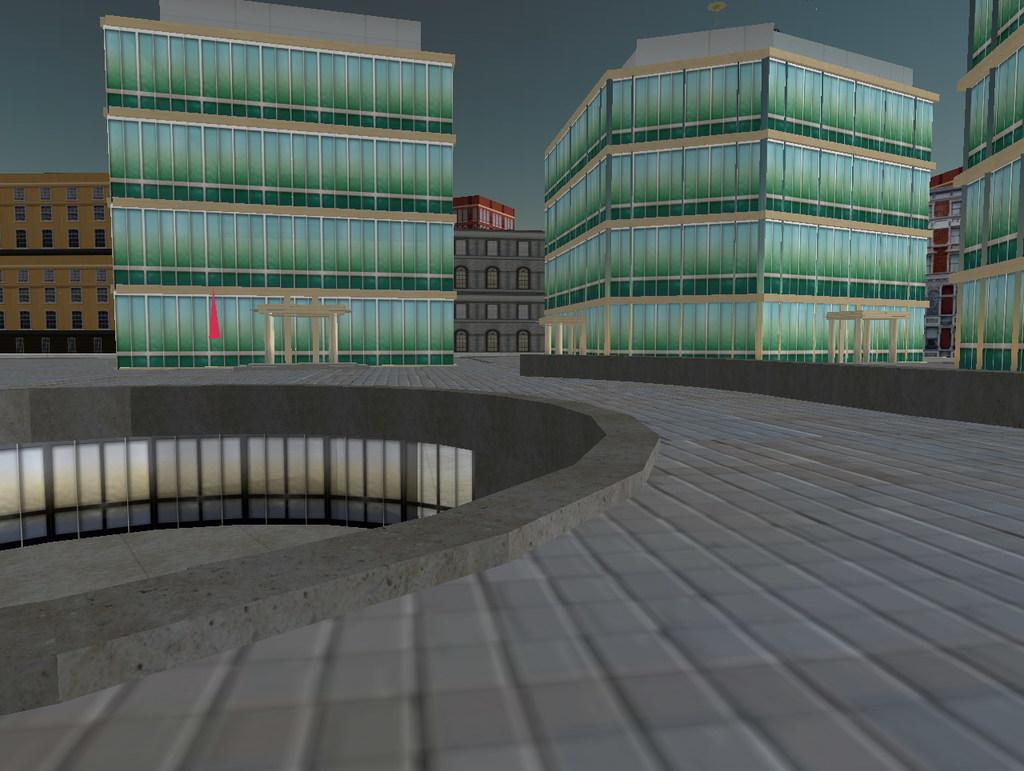What is the main subject of the image? The main subject of the image is a graphic representation of a town. Can you describe the background of the image? There are many buildings in the background of the image. What type of twig can be seen in the image? There is no twig present in the image; it is a graphic representation of a town with buildings in the background. 